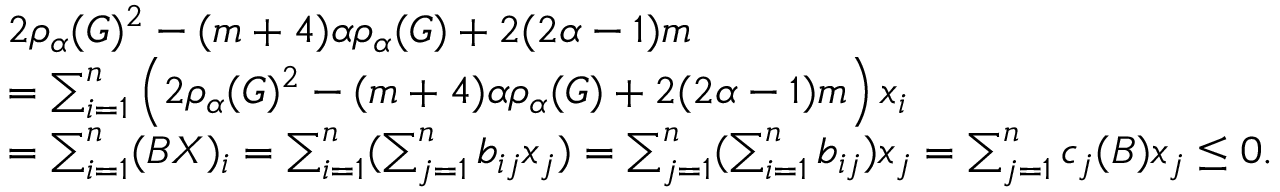Convert formula to latex. <formula><loc_0><loc_0><loc_500><loc_500>\begin{array} { r l } & { 2 \rho _ { \alpha } ( G ) ^ { 2 } - ( m + 4 ) \alpha \rho _ { \alpha } ( G ) + 2 ( 2 \alpha - 1 ) m } \\ & { = \sum _ { i = 1 } ^ { n } \left ( 2 \rho _ { \alpha } ( G ) ^ { 2 } - ( m + 4 ) \alpha \rho _ { \alpha } ( G ) + 2 ( 2 \alpha - 1 ) m \right ) x _ { i } } \\ & { = \sum _ { i = 1 } ^ { n } ( B X ) _ { i } = \sum _ { i = 1 } ^ { n } ( \sum _ { j = 1 } ^ { n } b _ { i j } x _ { j } ) = \sum _ { j = 1 } ^ { n } ( \sum _ { i = 1 } ^ { n } b _ { i j } ) x _ { j } = \sum _ { j = 1 } ^ { n } c _ { j } ( B ) x _ { j } \leq 0 . } \end{array}</formula> 